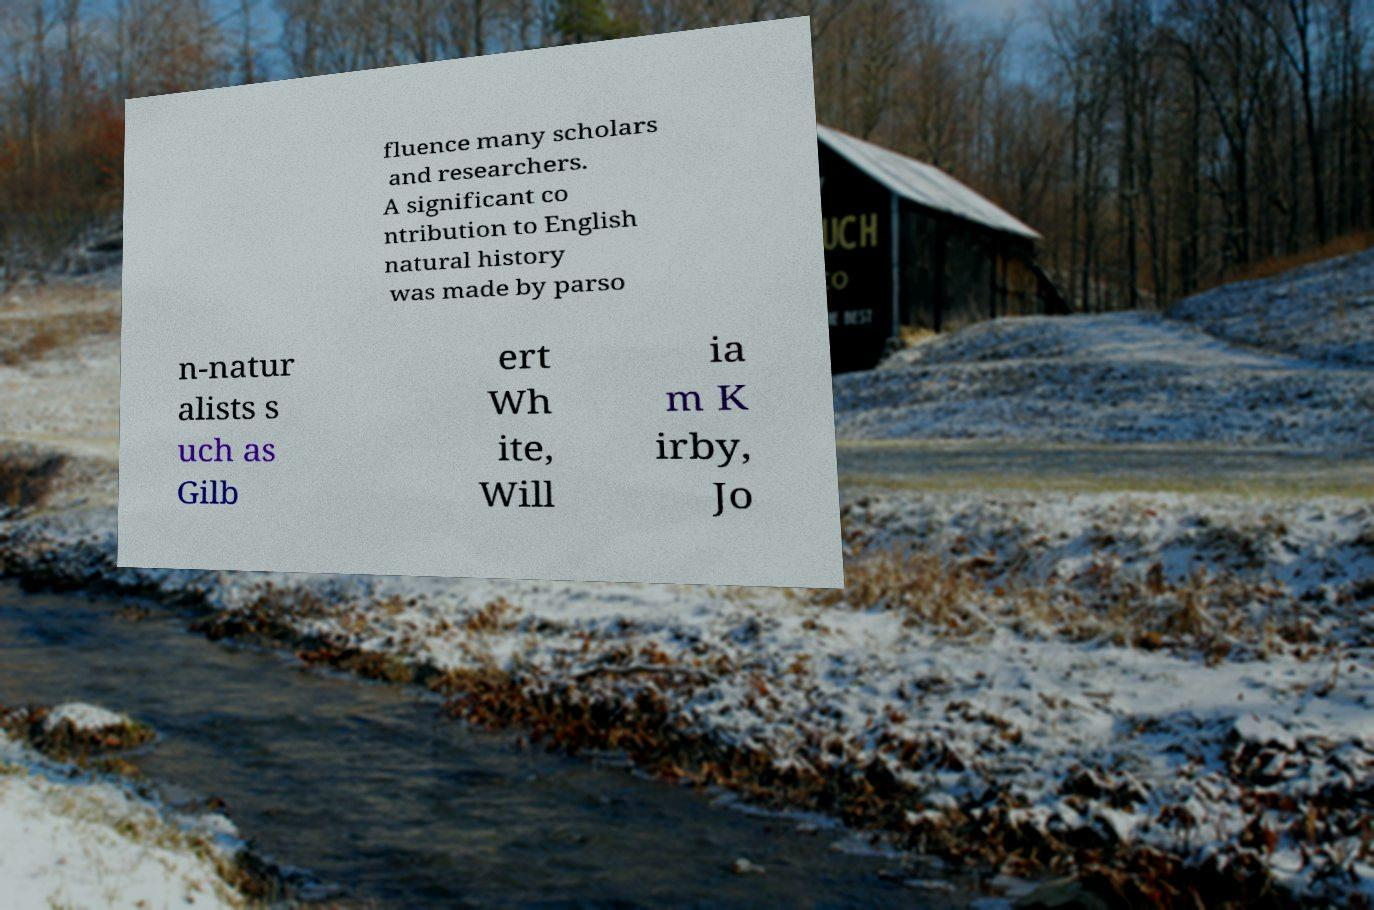For documentation purposes, I need the text within this image transcribed. Could you provide that? fluence many scholars and researchers. A significant co ntribution to English natural history was made by parso n-natur alists s uch as Gilb ert Wh ite, Will ia m K irby, Jo 